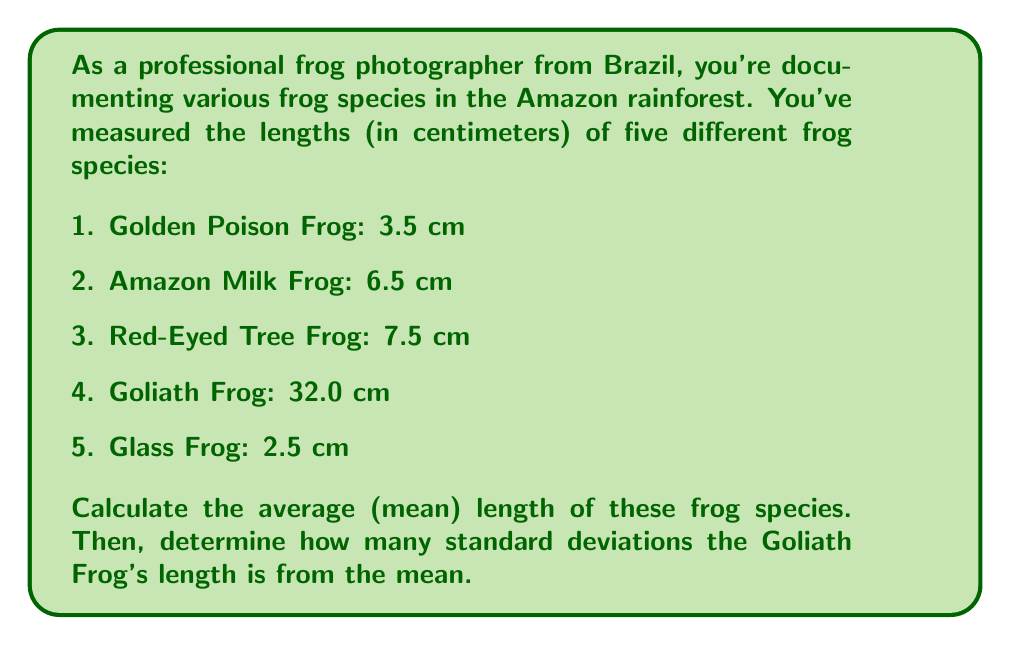Provide a solution to this math problem. To solve this problem, we'll follow these steps:

1. Calculate the mean length of the frogs
2. Calculate the variance
3. Calculate the standard deviation
4. Determine how many standard deviations the Goliath Frog is from the mean

Step 1: Calculate the mean length

The mean is calculated by summing all values and dividing by the number of values.

$$ \text{Mean} = \frac{\sum_{i=1}^{n} x_i}{n} $$

$$ \text{Mean} = \frac{3.5 + 6.5 + 7.5 + 32.0 + 2.5}{5} = \frac{52}{5} = 10.4 \text{ cm} $$

Step 2: Calculate the variance

The variance is the average of the squared differences from the mean.

$$ \text{Variance} = \frac{\sum_{i=1}^{n} (x_i - \text{Mean})^2}{n} $$

$$ \text{Variance} = \frac{(3.5-10.4)^2 + (6.5-10.4)^2 + (7.5-10.4)^2 + (32.0-10.4)^2 + (2.5-10.4)^2}{5} $$
$$ = \frac{(-6.9)^2 + (-3.9)^2 + (-2.9)^2 + (21.6)^2 + (-7.9)^2}{5} $$
$$ = \frac{47.61 + 15.21 + 8.41 + 466.56 + 62.41}{5} = \frac{600.2}{5} = 120.04 \text{ cm}^2 $$

Step 3: Calculate the standard deviation

The standard deviation is the square root of the variance.

$$ \text{Standard Deviation} = \sqrt{\text{Variance}} = \sqrt{120.04} \approx 10.96 \text{ cm} $$

Step 4: Determine how many standard deviations the Goliath Frog is from the mean

To do this, we calculate the z-score:

$$ z = \frac{x - \text{Mean}}{\text{Standard Deviation}} $$

For the Goliath Frog:

$$ z = \frac{32.0 - 10.4}{10.96} \approx 1.97 $$

Therefore, the Goliath Frog's length is approximately 1.97 standard deviations above the mean.
Answer: The average (mean) length of the frog species is 10.4 cm, and the Goliath Frog's length is approximately 1.97 standard deviations above the mean. 